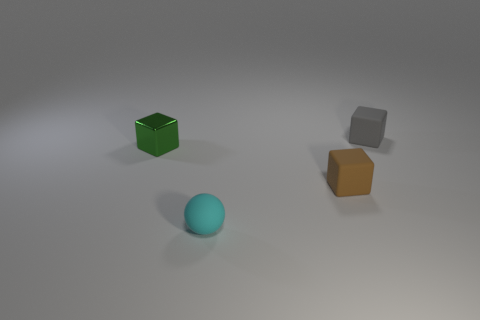Add 4 rubber blocks. How many objects exist? 8 Subtract all blocks. How many objects are left? 1 Subtract all small purple things. Subtract all brown rubber cubes. How many objects are left? 3 Add 4 green blocks. How many green blocks are left? 5 Add 2 small green things. How many small green things exist? 3 Subtract 0 brown cylinders. How many objects are left? 4 